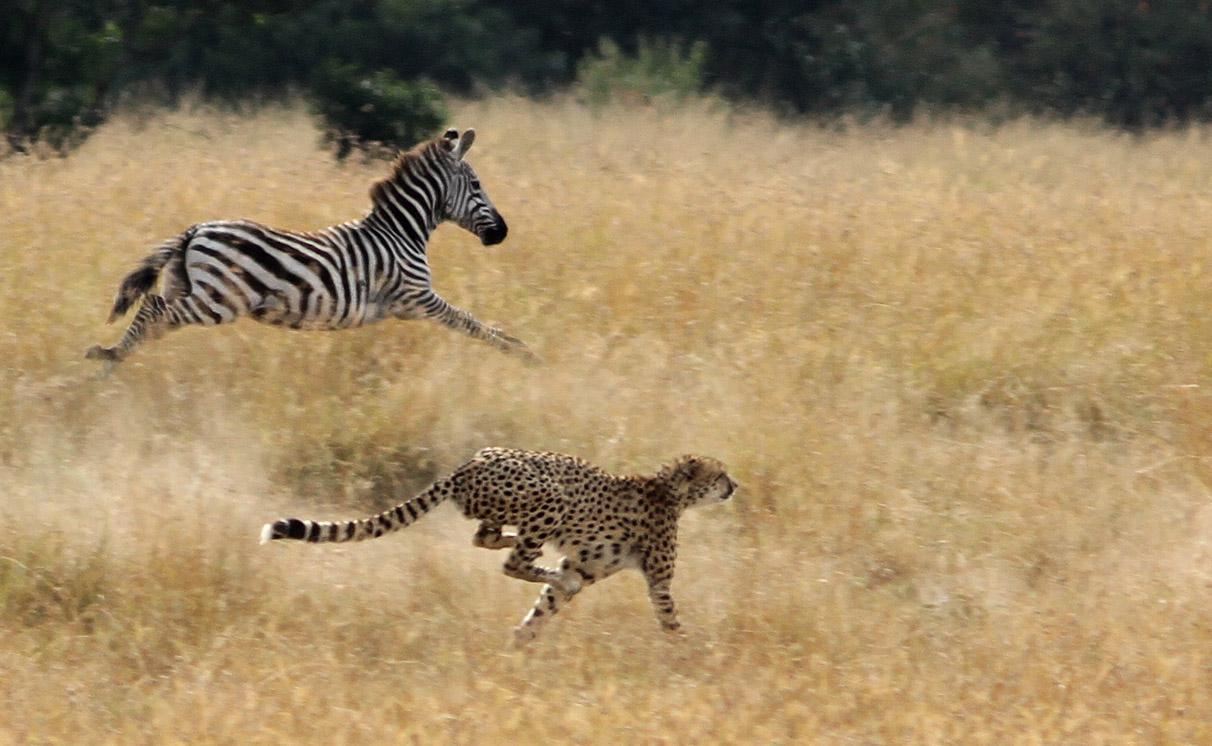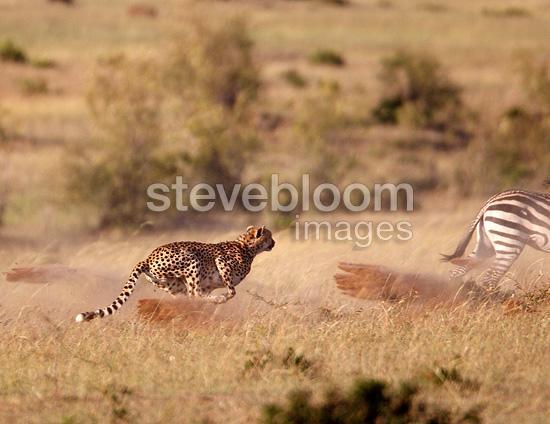The first image is the image on the left, the second image is the image on the right. Analyze the images presented: Is the assertion "A lone cheetah can be seen chasing at least one zebra." valid? Answer yes or no. Yes. The first image is the image on the left, the second image is the image on the right. Analyze the images presented: Is the assertion "One image shows a single cheetah behind at least one zebra and bounding rightward across the field towards the zebra." valid? Answer yes or no. Yes. 